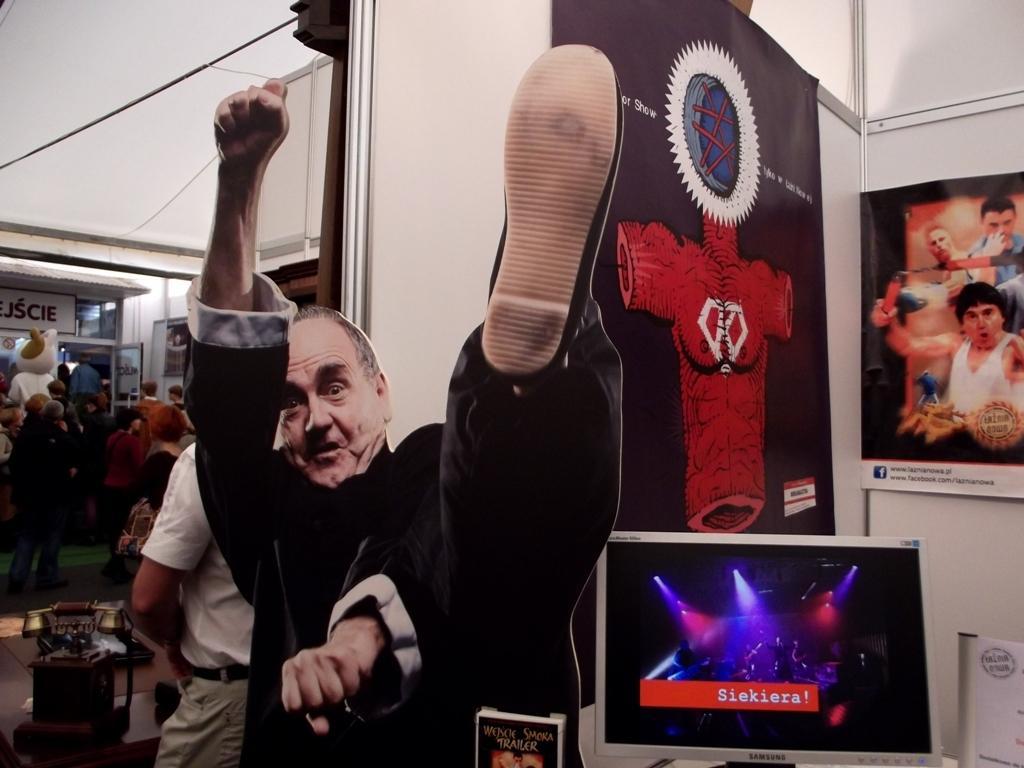Please provide a concise description of this image. This image consists of a poster of a man. On the right, we can see a screen and a banner. On the left, there are many persons. And we can see a telephone. At the top, there is a roof. 